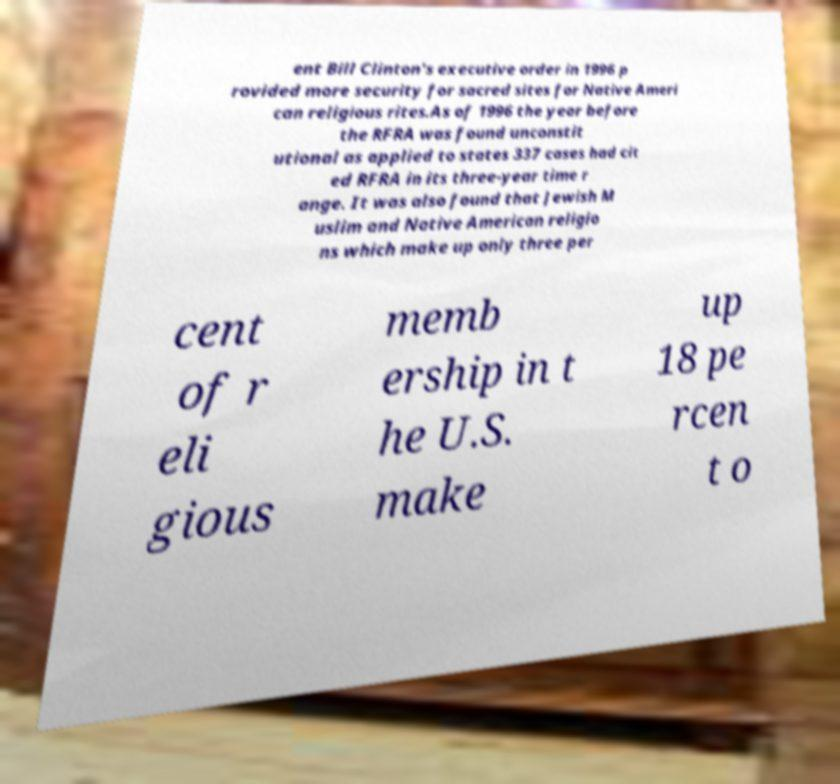Could you assist in decoding the text presented in this image and type it out clearly? ent Bill Clinton's executive order in 1996 p rovided more security for sacred sites for Native Ameri can religious rites.As of 1996 the year before the RFRA was found unconstit utional as applied to states 337 cases had cit ed RFRA in its three-year time r ange. It was also found that Jewish M uslim and Native American religio ns which make up only three per cent of r eli gious memb ership in t he U.S. make up 18 pe rcen t o 